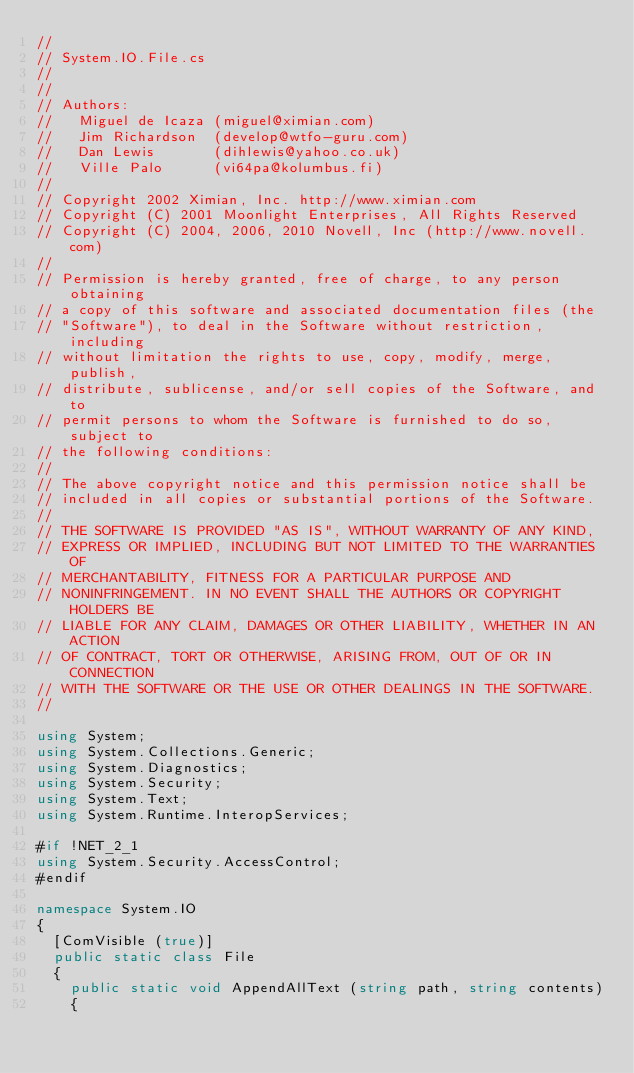<code> <loc_0><loc_0><loc_500><loc_500><_C#_>// 
// System.IO.File.cs 
//
// 
// Authors:
//   Miguel de Icaza (miguel@ximian.com)
//   Jim Richardson  (develop@wtfo-guru.com)
//   Dan Lewis       (dihlewis@yahoo.co.uk)
//   Ville Palo      (vi64pa@kolumbus.fi)
//
// Copyright 2002 Ximian, Inc. http://www.ximian.com
// Copyright (C) 2001 Moonlight Enterprises, All Rights Reserved
// Copyright (C) 2004, 2006, 2010 Novell, Inc (http://www.novell.com)
//
// Permission is hereby granted, free of charge, to any person obtaining
// a copy of this software and associated documentation files (the
// "Software"), to deal in the Software without restriction, including
// without limitation the rights to use, copy, modify, merge, publish,
// distribute, sublicense, and/or sell copies of the Software, and to
// permit persons to whom the Software is furnished to do so, subject to
// the following conditions:
// 
// The above copyright notice and this permission notice shall be
// included in all copies or substantial portions of the Software.
// 
// THE SOFTWARE IS PROVIDED "AS IS", WITHOUT WARRANTY OF ANY KIND,
// EXPRESS OR IMPLIED, INCLUDING BUT NOT LIMITED TO THE WARRANTIES OF
// MERCHANTABILITY, FITNESS FOR A PARTICULAR PURPOSE AND
// NONINFRINGEMENT. IN NO EVENT SHALL THE AUTHORS OR COPYRIGHT HOLDERS BE
// LIABLE FOR ANY CLAIM, DAMAGES OR OTHER LIABILITY, WHETHER IN AN ACTION
// OF CONTRACT, TORT OR OTHERWISE, ARISING FROM, OUT OF OR IN CONNECTION
// WITH THE SOFTWARE OR THE USE OR OTHER DEALINGS IN THE SOFTWARE.
//

using System;
using System.Collections.Generic;
using System.Diagnostics;
using System.Security;
using System.Text;
using System.Runtime.InteropServices;

#if !NET_2_1
using System.Security.AccessControl;
#endif

namespace System.IO
{
	[ComVisible (true)]
	public static class File
	{
		public static void AppendAllText (string path, string contents)
		{</code> 